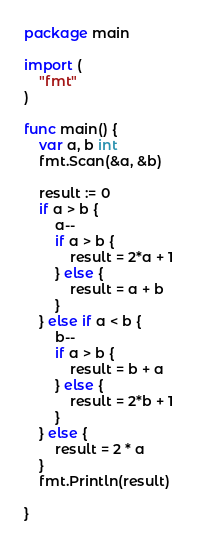Convert code to text. <code><loc_0><loc_0><loc_500><loc_500><_Go_>package main

import (
	"fmt"
)

func main() {
	var a, b int
	fmt.Scan(&a, &b)

	result := 0
	if a > b {
		a--
		if a > b {
			result = 2*a + 1
		} else {
			result = a + b
		}
	} else if a < b {
		b--
		if a > b {
			result = b + a
		} else {
			result = 2*b + 1
		}
	} else {
		result = 2 * a
	}
	fmt.Println(result)

}
</code> 